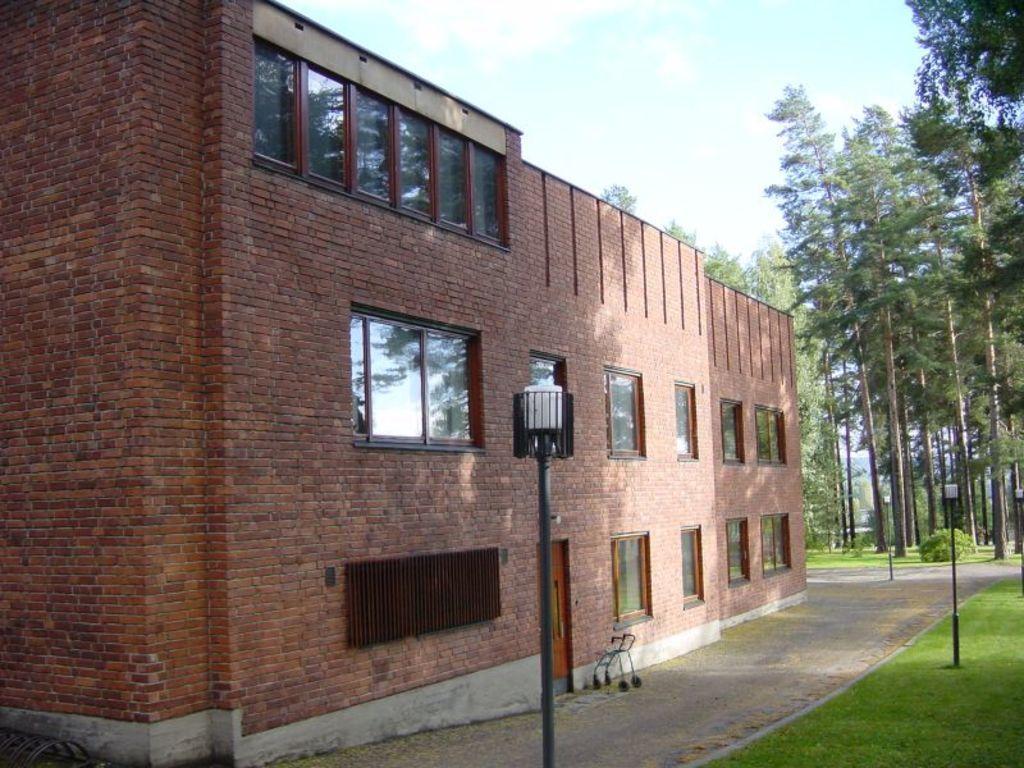In one or two sentences, can you explain what this image depicts? In this image I can see building in brown color. I can also see few windows, light poles, trees in green color and sky in white and blue color. 